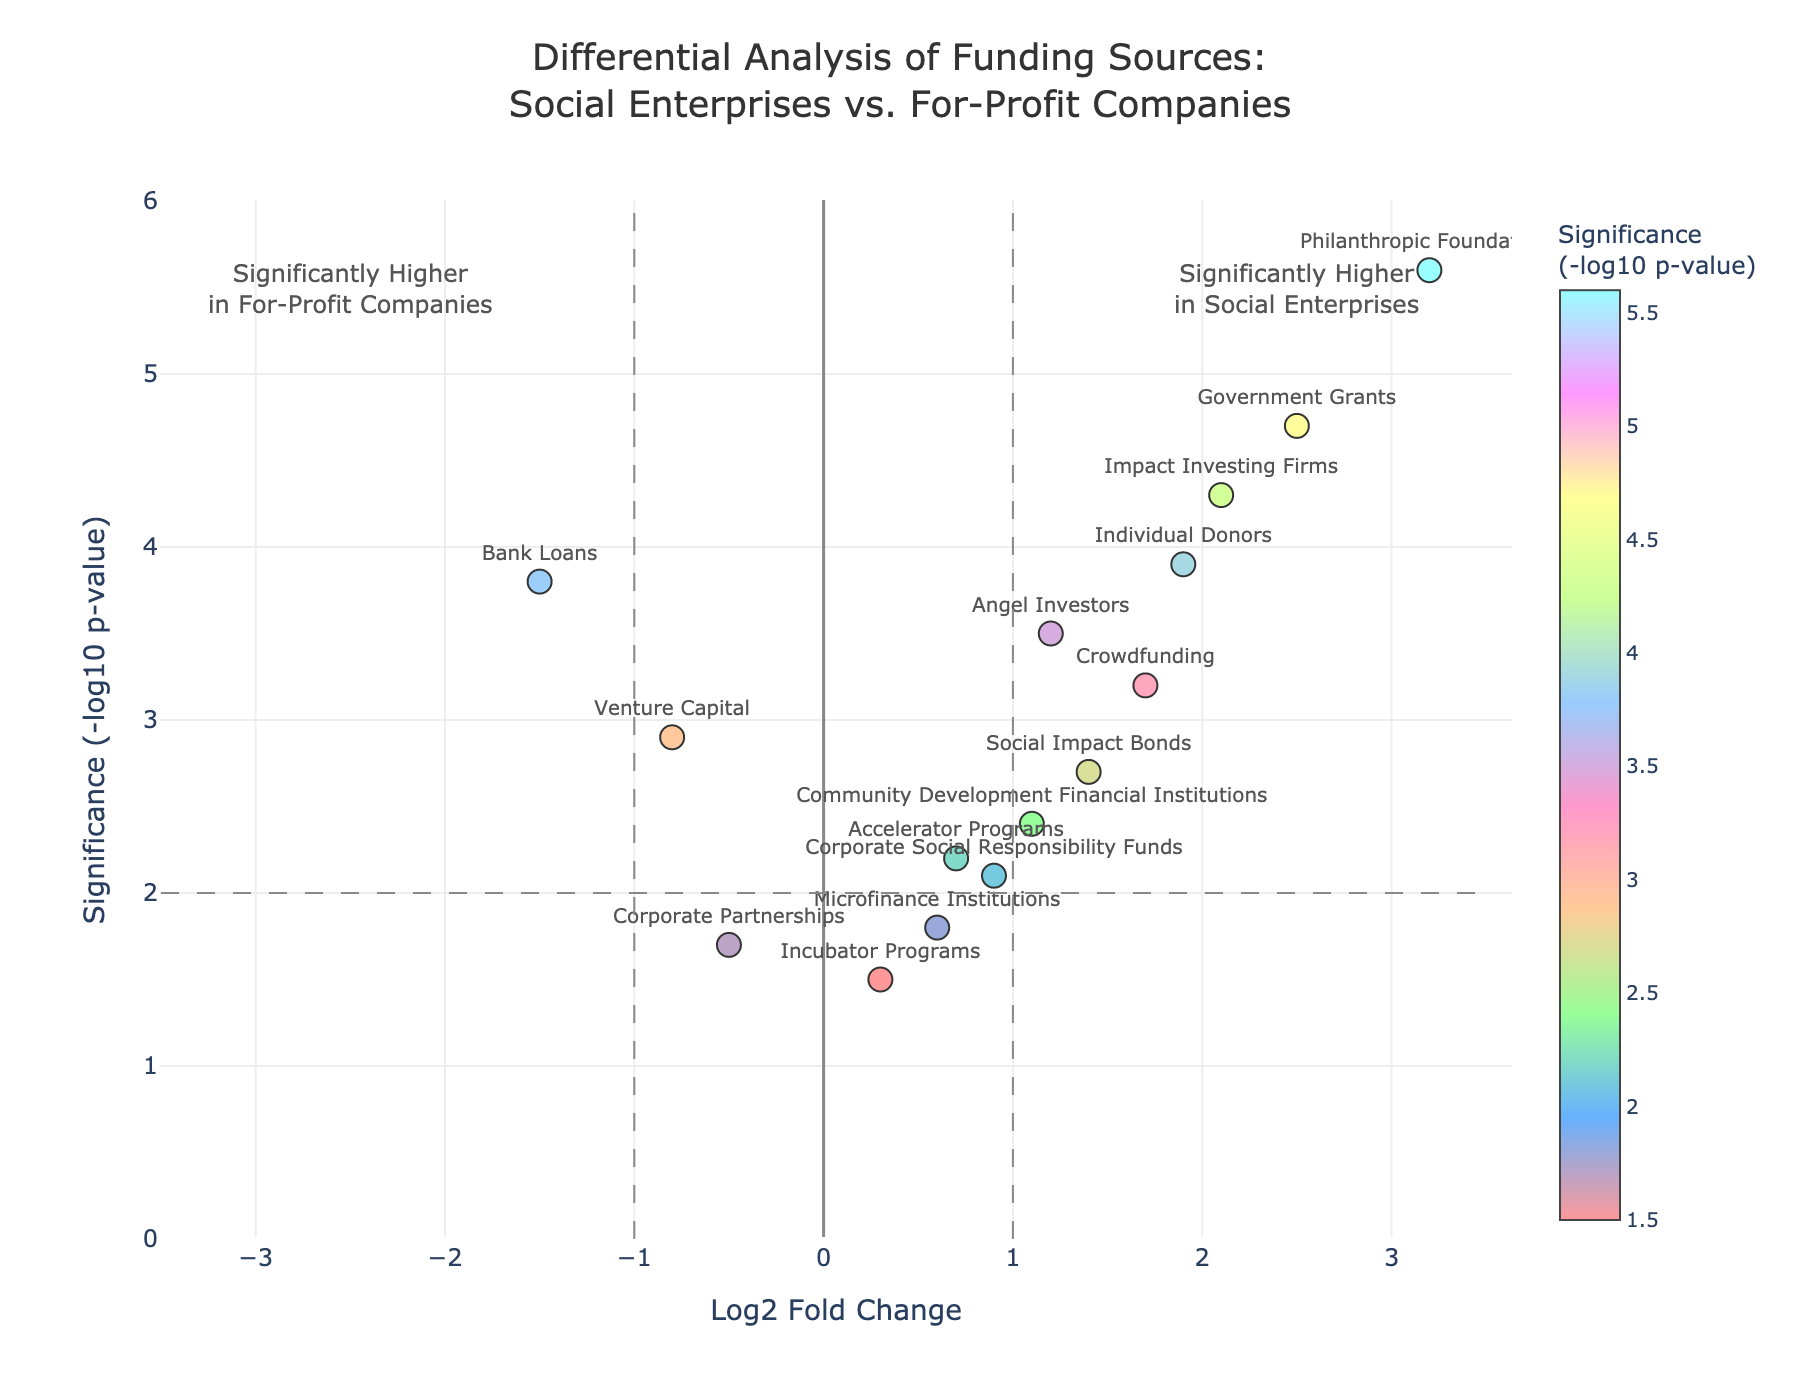What is the title of the figure? The title is usually located at the top part of the plot and describes the content of the figure. In this case, it is set up to give a clear idea of what the plot represents.
Answer: Differential Analysis of Funding Sources: Social Enterprises vs. For-Profit Companies Which funding source has the highest significance level, and what is its corresponding negative log10 p-value? Look for the data point that is positioned highest on the y-axis. According to the hover text, identify the name of the funding source and the corresponding negative log10 p-value.
Answer: Philanthropic Foundations, 5.6 Are there any funding sources that are significantly higher in social enterprises compared to for-profit companies and have a log2 fold change greater than 2? Check for data points right of the vertical line x=1 and above the significance threshold line at y=2. Identify any points above x=2.
Answer: Government Grants, Philanthropic Foundations Which funding source has negative log2 fold change but is still significant (negative log10 p-value > 2)? Identify data points that are left of the center (negative x-axis) and above the horizontal line at y=2 to filter out significant ones with negative log fold change.
Answer: Venture Capital, Bank Loans How many funding sources have a log2 fold change between -1 and 1 but are not significant (negative log10 p-value < 2)? Look within the shaded area between x=-1 and x=1, and below the horizontal threshold line at y=2. Count the relevant data points.
Answer: 4 What is the log2 fold change and significance of Impact Investing Firms? Locate the data point labeled "Impact Investing Firms" from the text on the figure and determine its x and y coordinates based on hover text information.
Answer: Log2 Fold Change: 2.1, Significance: -log10 p-value: 4.3 Between Microfinance Institutions and Corporate Partnerships, which has a lower significance level and by how much? Compare the y-axis values (negative log10 p-value) for both Microfinance Institutions and Corporate Partnerships. Subtract the lesser value from the greater.
Answer: Corporate Partnerships, by 0.7 What quadrant would Crowdfunding be located in based on log2 fold change and significance? Analyze the x-value (log2 fold change) and y-value (negative log10 p-value). Determine in which quadrant the data point falls based on its position relative to the axes and threshold lines.
Answer: Crowdfunding is in the right quadrant, above the x-axis and the horizontal threshold, indicating higher in social enterprises and significant Which funding sources have a negative log2 fold change but are not below the significance threshold? Look for data points to the left of x=0 (negative side) but above the horizontal line at y=2. Identify the funding sources that meet these criteria.
Answer: Venture Capital, Bank Loans Is there a general trend observed between significance and log2 fold change among the funding sources? Assess the distribution pattern of the points on the figure, whether higher significance correlates with more positive or negative log2 fold change.
Answer: Higher significance generally correlates with higher log2 fold change towards Social Enterprises 